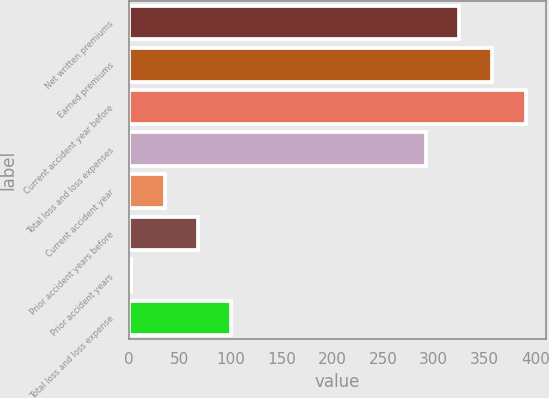Convert chart. <chart><loc_0><loc_0><loc_500><loc_500><bar_chart><fcel>Net written premiums<fcel>Earned premiums<fcel>Current accident year before<fcel>Total loss and loss expenses<fcel>Current accident year<fcel>Prior accident years before<fcel>Prior accident years<fcel>Total loss and loss expense<nl><fcel>324.86<fcel>357.72<fcel>390.58<fcel>292<fcel>35.25<fcel>68.11<fcel>2.39<fcel>100.97<nl></chart> 